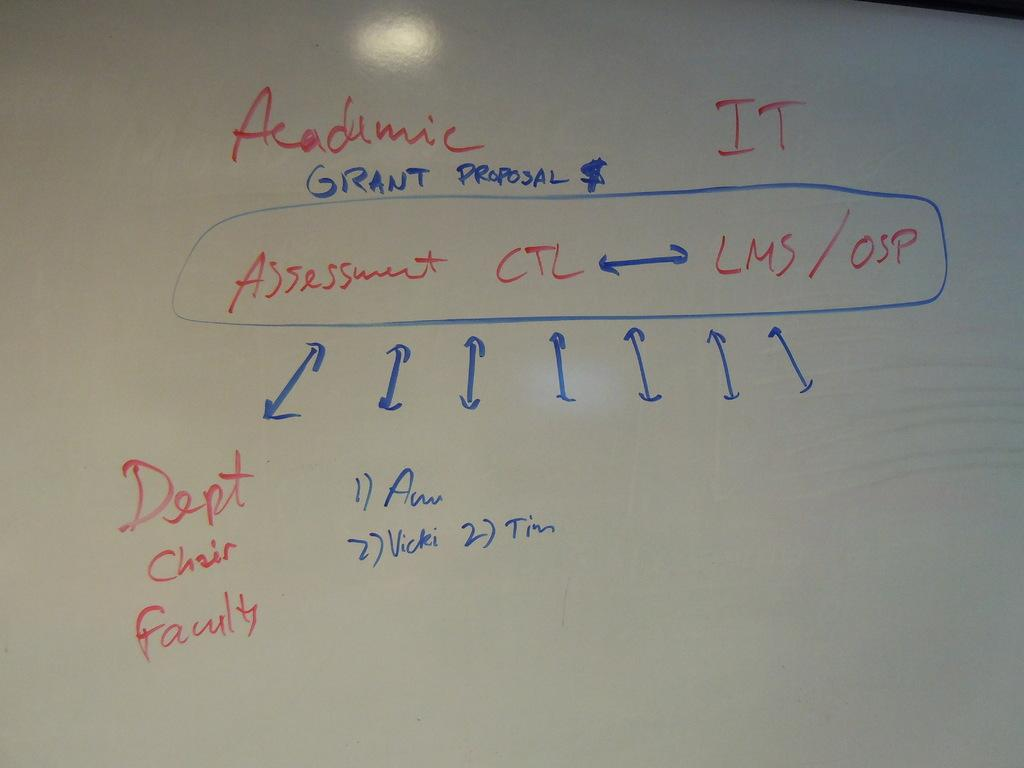Provide a one-sentence caption for the provided image. A board with writing in red and blue with the words Dept Chair Faulty toward the bottom of the board. 